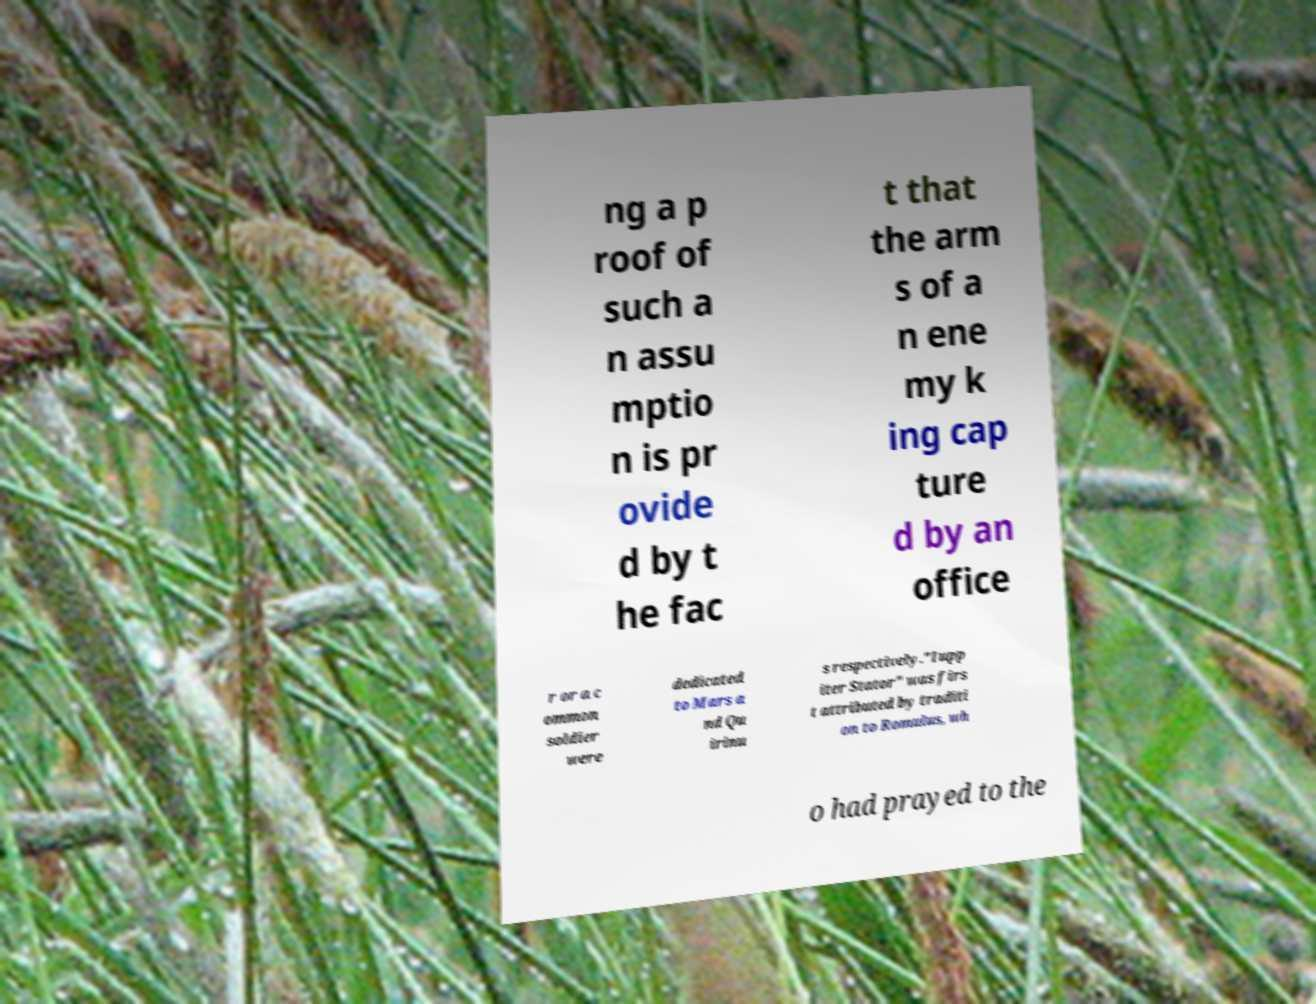For documentation purposes, I need the text within this image transcribed. Could you provide that? ng a p roof of such a n assu mptio n is pr ovide d by t he fac t that the arm s of a n ene my k ing cap ture d by an office r or a c ommon soldier were dedicated to Mars a nd Qu irinu s respectively."Iupp iter Stator" was firs t attributed by traditi on to Romulus, wh o had prayed to the 